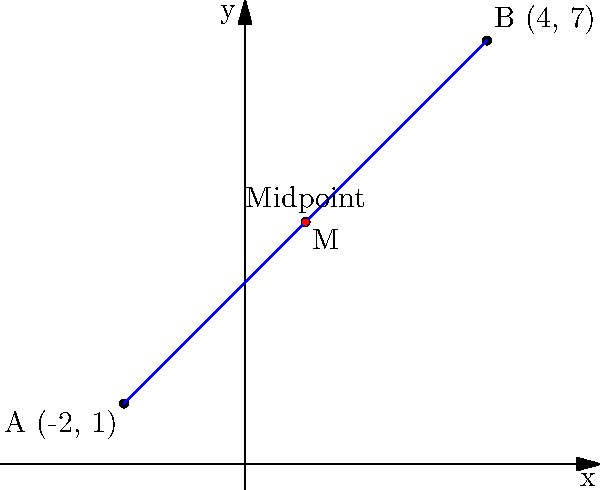As you're planning a romantic evening, you decide to surprise your date by meeting at the midpoint between your two favorite spots in the city. Your spot is represented by point A (-2, 1) on a coordinate plane, and your date's spot is represented by point B (4, 7). Find the coordinates of the midpoint M where you'll meet. To find the midpoint of a line segment connecting two points, we use the midpoint formula:

$$ M = (\frac{x_1 + x_2}{2}, \frac{y_1 + y_2}{2}) $$

Where $(x_1, y_1)$ are the coordinates of point A and $(x_2, y_2)$ are the coordinates of point B.

Step 1: Identify the coordinates
A: $(-2, 1)$
B: $(4, 7)$

Step 2: Apply the midpoint formula
$x$-coordinate of M: $\frac{x_1 + x_2}{2} = \frac{-2 + 4}{2} = \frac{2}{2} = 1$
$y$-coordinate of M: $\frac{y_1 + y_2}{2} = \frac{1 + 7}{2} = \frac{8}{2} = 4$

Step 3: Combine the coordinates
The midpoint M is $(1, 4)$
Answer: $(1, 4)$ 